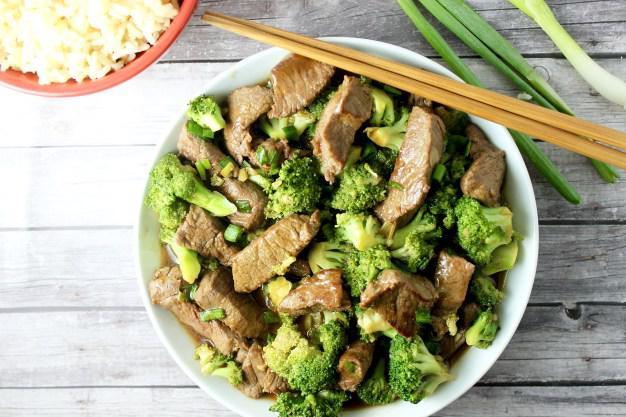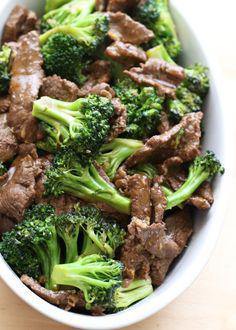The first image is the image on the left, the second image is the image on the right. Considering the images on both sides, is "There are two white bowls." valid? Answer yes or no. Yes. The first image is the image on the left, the second image is the image on the right. For the images displayed, is the sentence "The left and right image contains the same number of white bowls with broccoli." factually correct? Answer yes or no. Yes. 